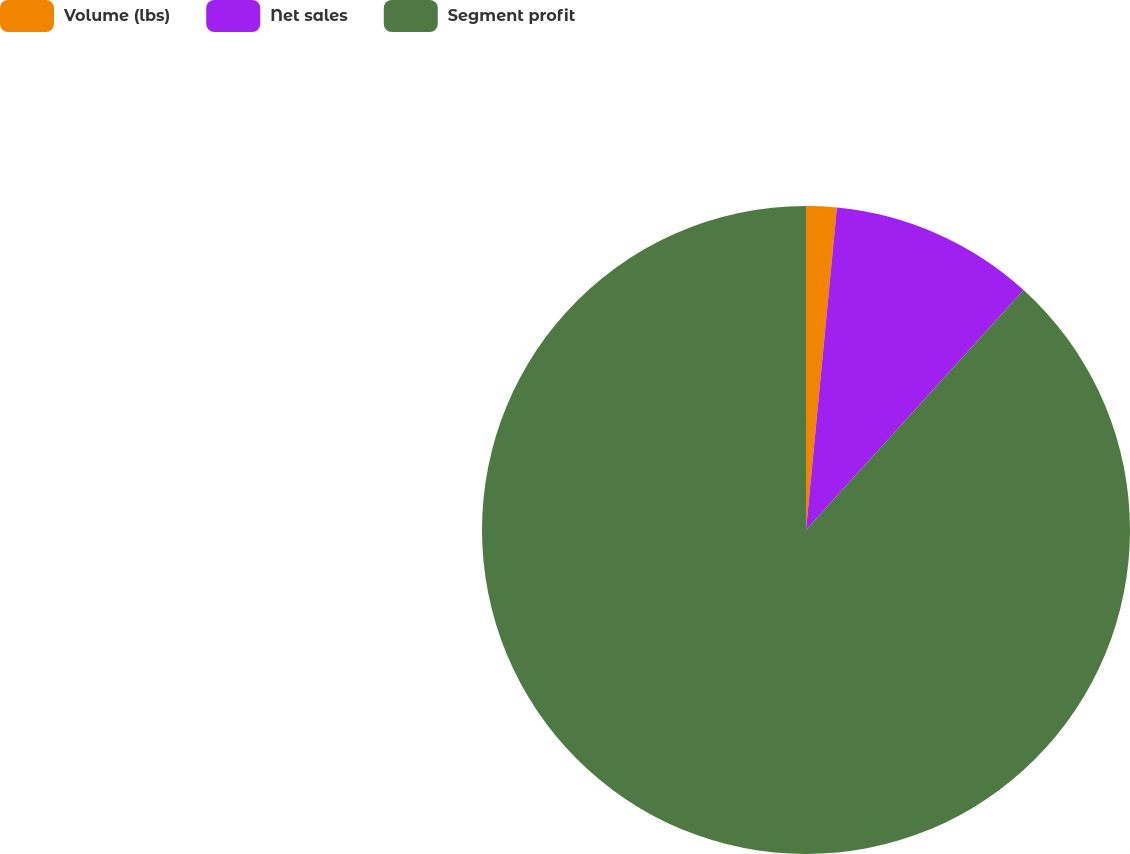<chart> <loc_0><loc_0><loc_500><loc_500><pie_chart><fcel>Volume (lbs)<fcel>Net sales<fcel>Segment profit<nl><fcel>1.52%<fcel>10.2%<fcel>88.28%<nl></chart> 